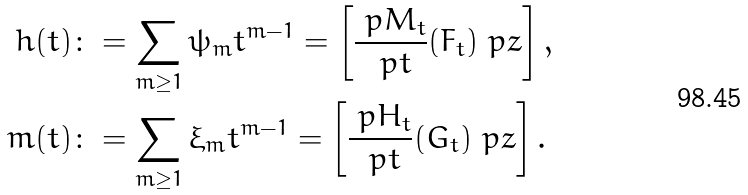Convert formula to latex. <formula><loc_0><loc_0><loc_500><loc_500>h ( t ) & \colon = \sum _ { m \geq 1 } \psi _ { m } t ^ { m - 1 } = \left [ \frac { \ p M _ { t } } { \ p t } ( F _ { t } ) \ p z \right ] , \\ m ( t ) & \colon = \sum _ { m \geq 1 } \xi _ { m } t ^ { m - 1 } = \left [ \frac { \ p H _ { t } } { \ p t } ( G _ { t } ) \ p z \right ] .</formula> 